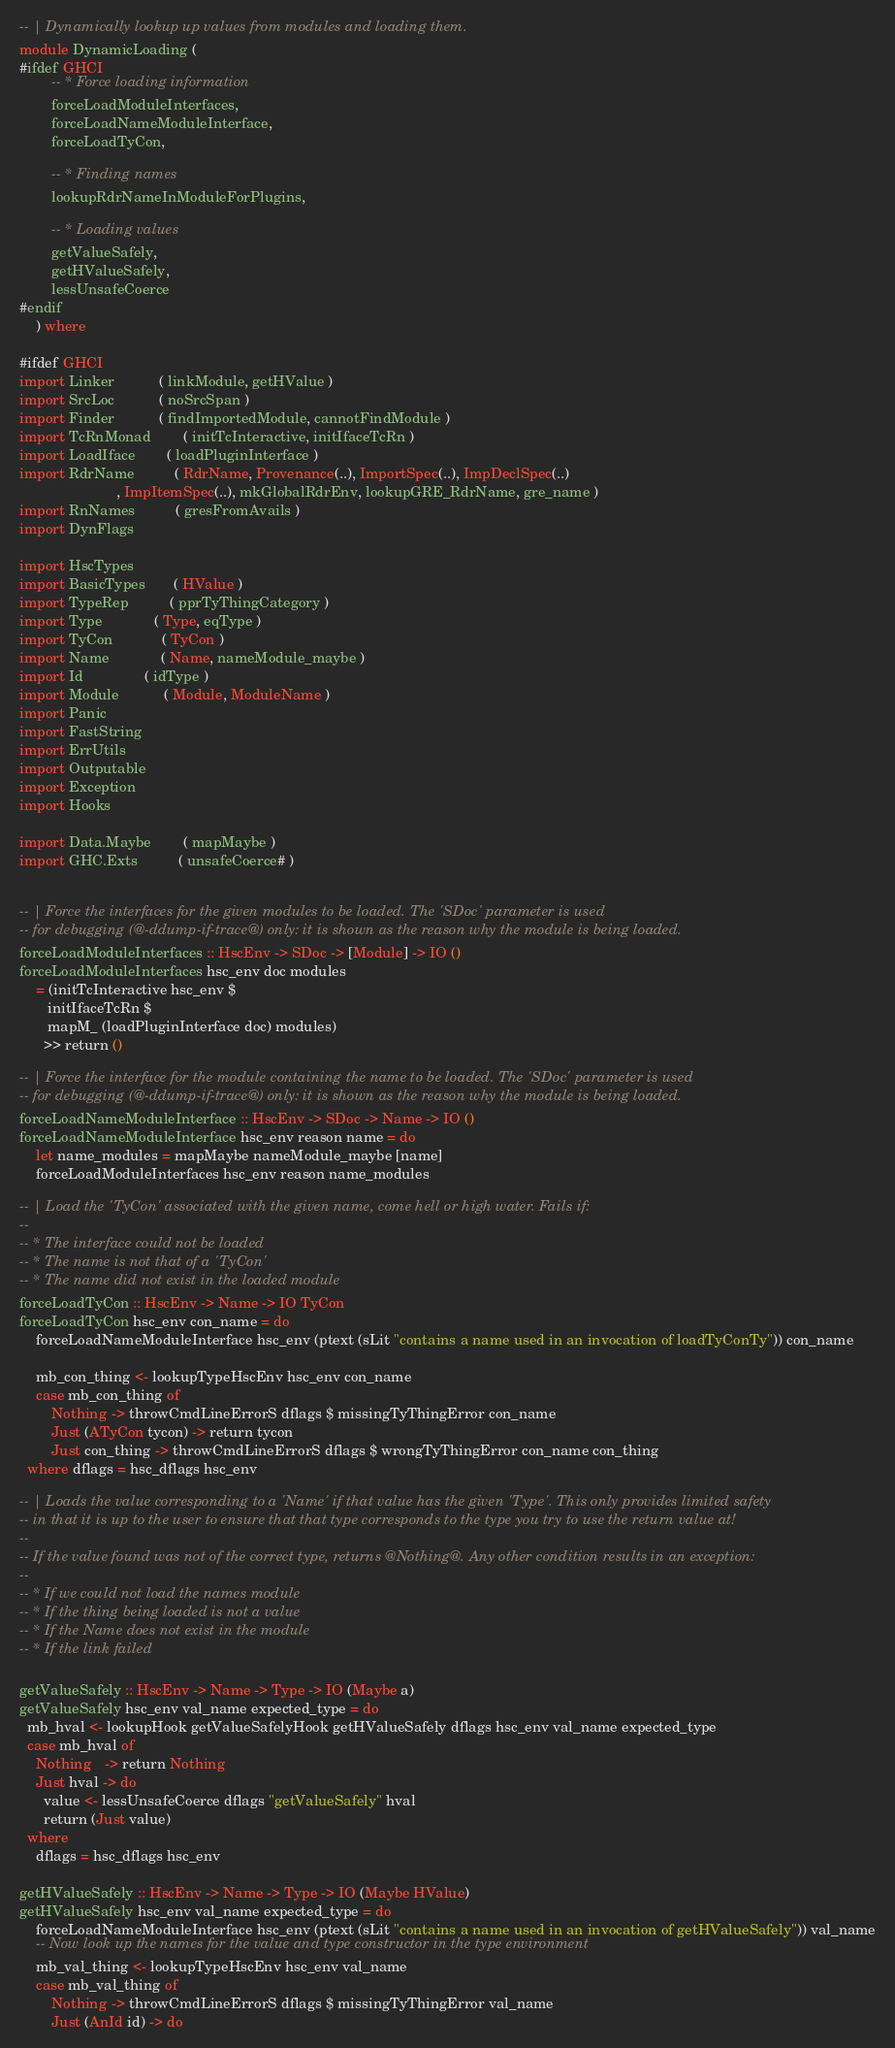Convert code to text. <code><loc_0><loc_0><loc_500><loc_500><_Haskell_>-- | Dynamically lookup up values from modules and loading them.
module DynamicLoading (
#ifdef GHCI
        -- * Force loading information
        forceLoadModuleInterfaces,
        forceLoadNameModuleInterface,
        forceLoadTyCon,

        -- * Finding names
        lookupRdrNameInModuleForPlugins,

        -- * Loading values
        getValueSafely,
        getHValueSafely,
        lessUnsafeCoerce
#endif
    ) where

#ifdef GHCI
import Linker           ( linkModule, getHValue )
import SrcLoc           ( noSrcSpan )
import Finder           ( findImportedModule, cannotFindModule )
import TcRnMonad        ( initTcInteractive, initIfaceTcRn )
import LoadIface        ( loadPluginInterface )
import RdrName          ( RdrName, Provenance(..), ImportSpec(..), ImpDeclSpec(..)
                        , ImpItemSpec(..), mkGlobalRdrEnv, lookupGRE_RdrName, gre_name )
import RnNames          ( gresFromAvails )
import DynFlags

import HscTypes
import BasicTypes       ( HValue )
import TypeRep          ( pprTyThingCategory )
import Type             ( Type, eqType )
import TyCon            ( TyCon )
import Name             ( Name, nameModule_maybe )
import Id               ( idType )
import Module           ( Module, ModuleName )
import Panic
import FastString
import ErrUtils
import Outputable
import Exception
import Hooks

import Data.Maybe        ( mapMaybe )
import GHC.Exts          ( unsafeCoerce# )


-- | Force the interfaces for the given modules to be loaded. The 'SDoc' parameter is used
-- for debugging (@-ddump-if-trace@) only: it is shown as the reason why the module is being loaded.
forceLoadModuleInterfaces :: HscEnv -> SDoc -> [Module] -> IO ()
forceLoadModuleInterfaces hsc_env doc modules
    = (initTcInteractive hsc_env $
       initIfaceTcRn $
       mapM_ (loadPluginInterface doc) modules) 
      >> return ()

-- | Force the interface for the module containing the name to be loaded. The 'SDoc' parameter is used
-- for debugging (@-ddump-if-trace@) only: it is shown as the reason why the module is being loaded.
forceLoadNameModuleInterface :: HscEnv -> SDoc -> Name -> IO ()
forceLoadNameModuleInterface hsc_env reason name = do
    let name_modules = mapMaybe nameModule_maybe [name]
    forceLoadModuleInterfaces hsc_env reason name_modules

-- | Load the 'TyCon' associated with the given name, come hell or high water. Fails if:
--
-- * The interface could not be loaded
-- * The name is not that of a 'TyCon'
-- * The name did not exist in the loaded module
forceLoadTyCon :: HscEnv -> Name -> IO TyCon
forceLoadTyCon hsc_env con_name = do
    forceLoadNameModuleInterface hsc_env (ptext (sLit "contains a name used in an invocation of loadTyConTy")) con_name
    
    mb_con_thing <- lookupTypeHscEnv hsc_env con_name
    case mb_con_thing of
        Nothing -> throwCmdLineErrorS dflags $ missingTyThingError con_name
        Just (ATyCon tycon) -> return tycon
        Just con_thing -> throwCmdLineErrorS dflags $ wrongTyThingError con_name con_thing
  where dflags = hsc_dflags hsc_env

-- | Loads the value corresponding to a 'Name' if that value has the given 'Type'. This only provides limited safety
-- in that it is up to the user to ensure that that type corresponds to the type you try to use the return value at!
--
-- If the value found was not of the correct type, returns @Nothing@. Any other condition results in an exception:
--
-- * If we could not load the names module
-- * If the thing being loaded is not a value
-- * If the Name does not exist in the module
-- * If the link failed

getValueSafely :: HscEnv -> Name -> Type -> IO (Maybe a)
getValueSafely hsc_env val_name expected_type = do
  mb_hval <- lookupHook getValueSafelyHook getHValueSafely dflags hsc_env val_name expected_type
  case mb_hval of
    Nothing   -> return Nothing
    Just hval -> do
      value <- lessUnsafeCoerce dflags "getValueSafely" hval
      return (Just value)
  where
    dflags = hsc_dflags hsc_env

getHValueSafely :: HscEnv -> Name -> Type -> IO (Maybe HValue)
getHValueSafely hsc_env val_name expected_type = do
    forceLoadNameModuleInterface hsc_env (ptext (sLit "contains a name used in an invocation of getHValueSafely")) val_name
    -- Now look up the names for the value and type constructor in the type environment
    mb_val_thing <- lookupTypeHscEnv hsc_env val_name
    case mb_val_thing of
        Nothing -> throwCmdLineErrorS dflags $ missingTyThingError val_name
        Just (AnId id) -> do</code> 